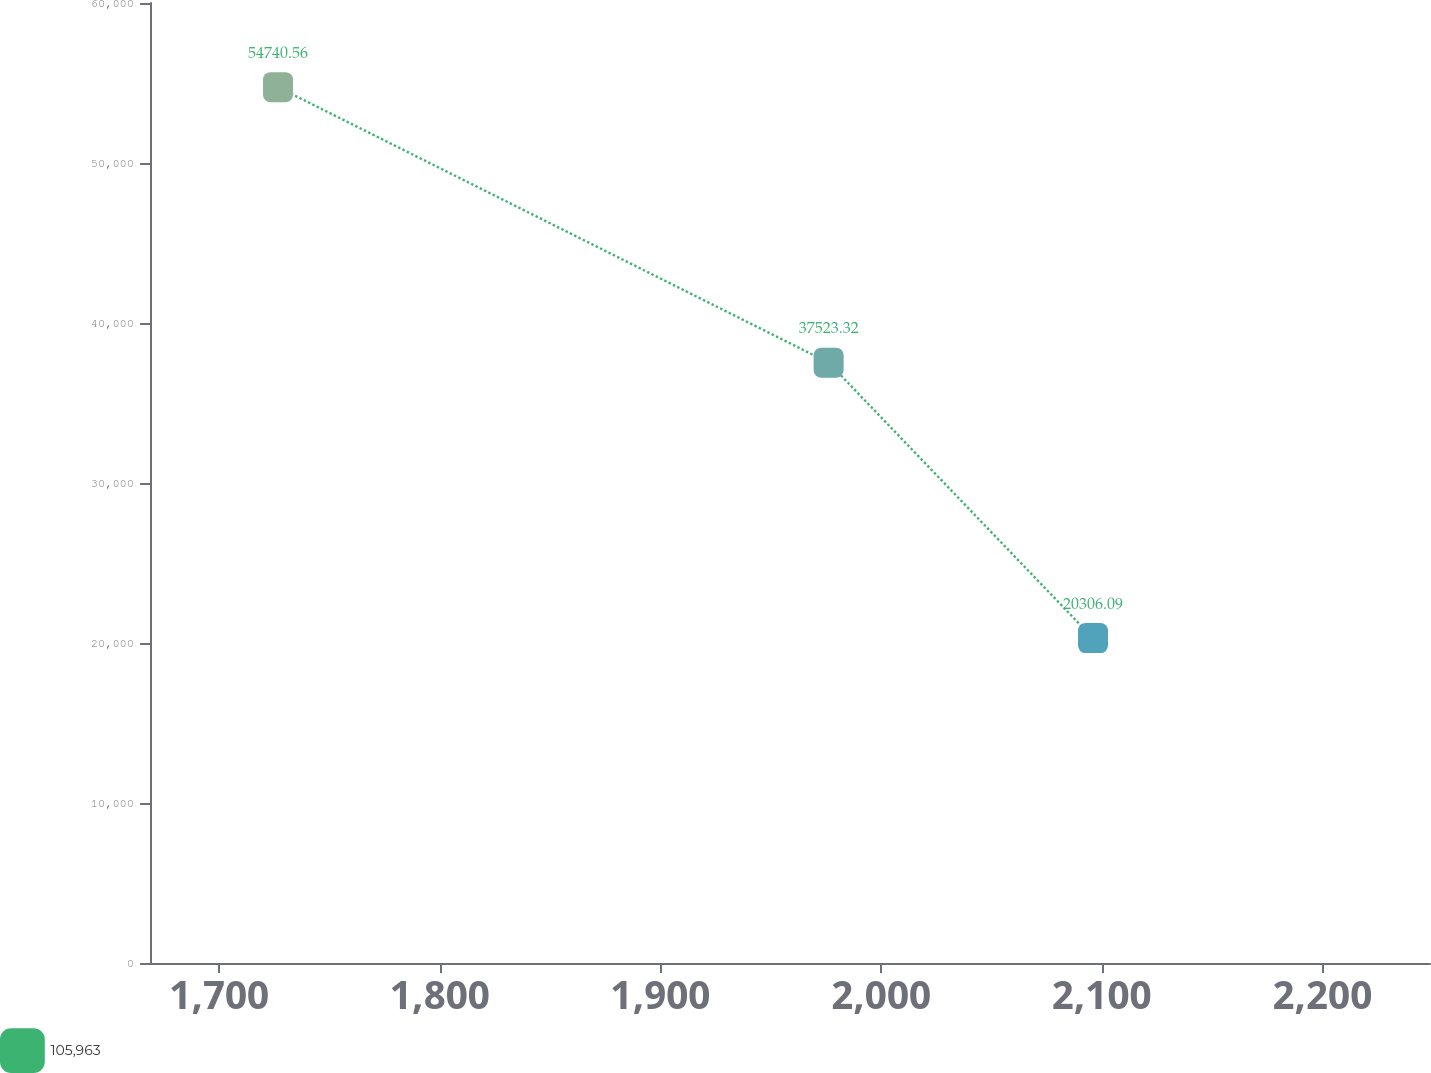Convert chart. <chart><loc_0><loc_0><loc_500><loc_500><line_chart><ecel><fcel>105,963<nl><fcel>1726.62<fcel>54740.6<nl><fcel>1976.22<fcel>37523.3<nl><fcel>2096.06<fcel>20306.1<nl><fcel>2306.84<fcel>192478<nl></chart> 